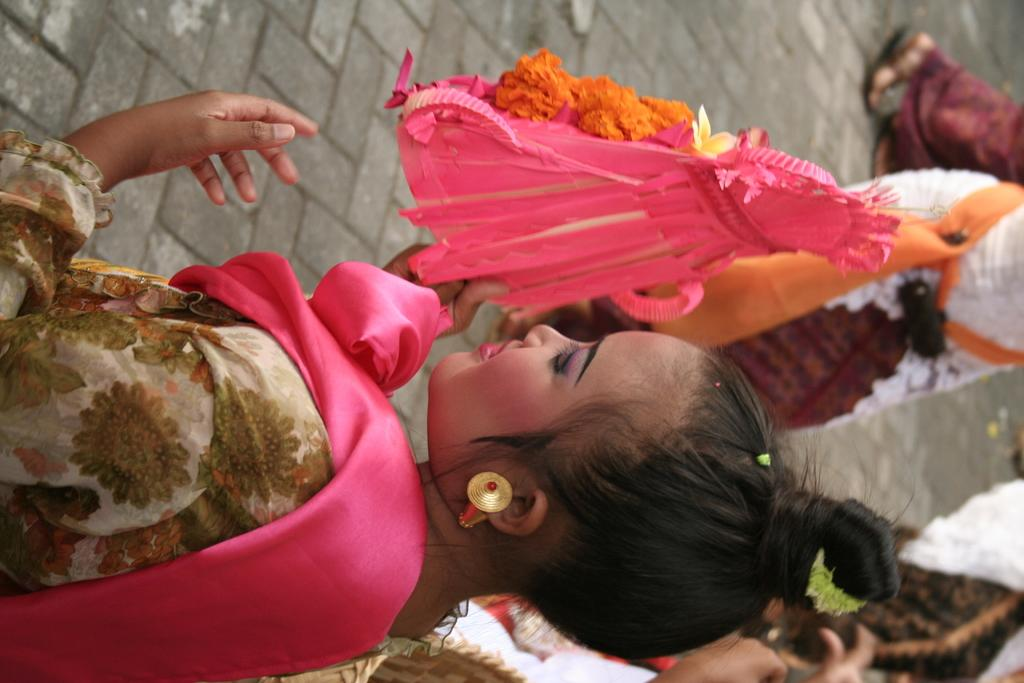Who is the main subject in the image? There is a woman in the image. What is the woman doing in the image? The woman is holding an object. Can you describe the background of the image? There are people in the background of the image. What type of crime is being committed by the giraffe in the image? There is no giraffe present in the image, and therefore no crime can be committed by a giraffe. 